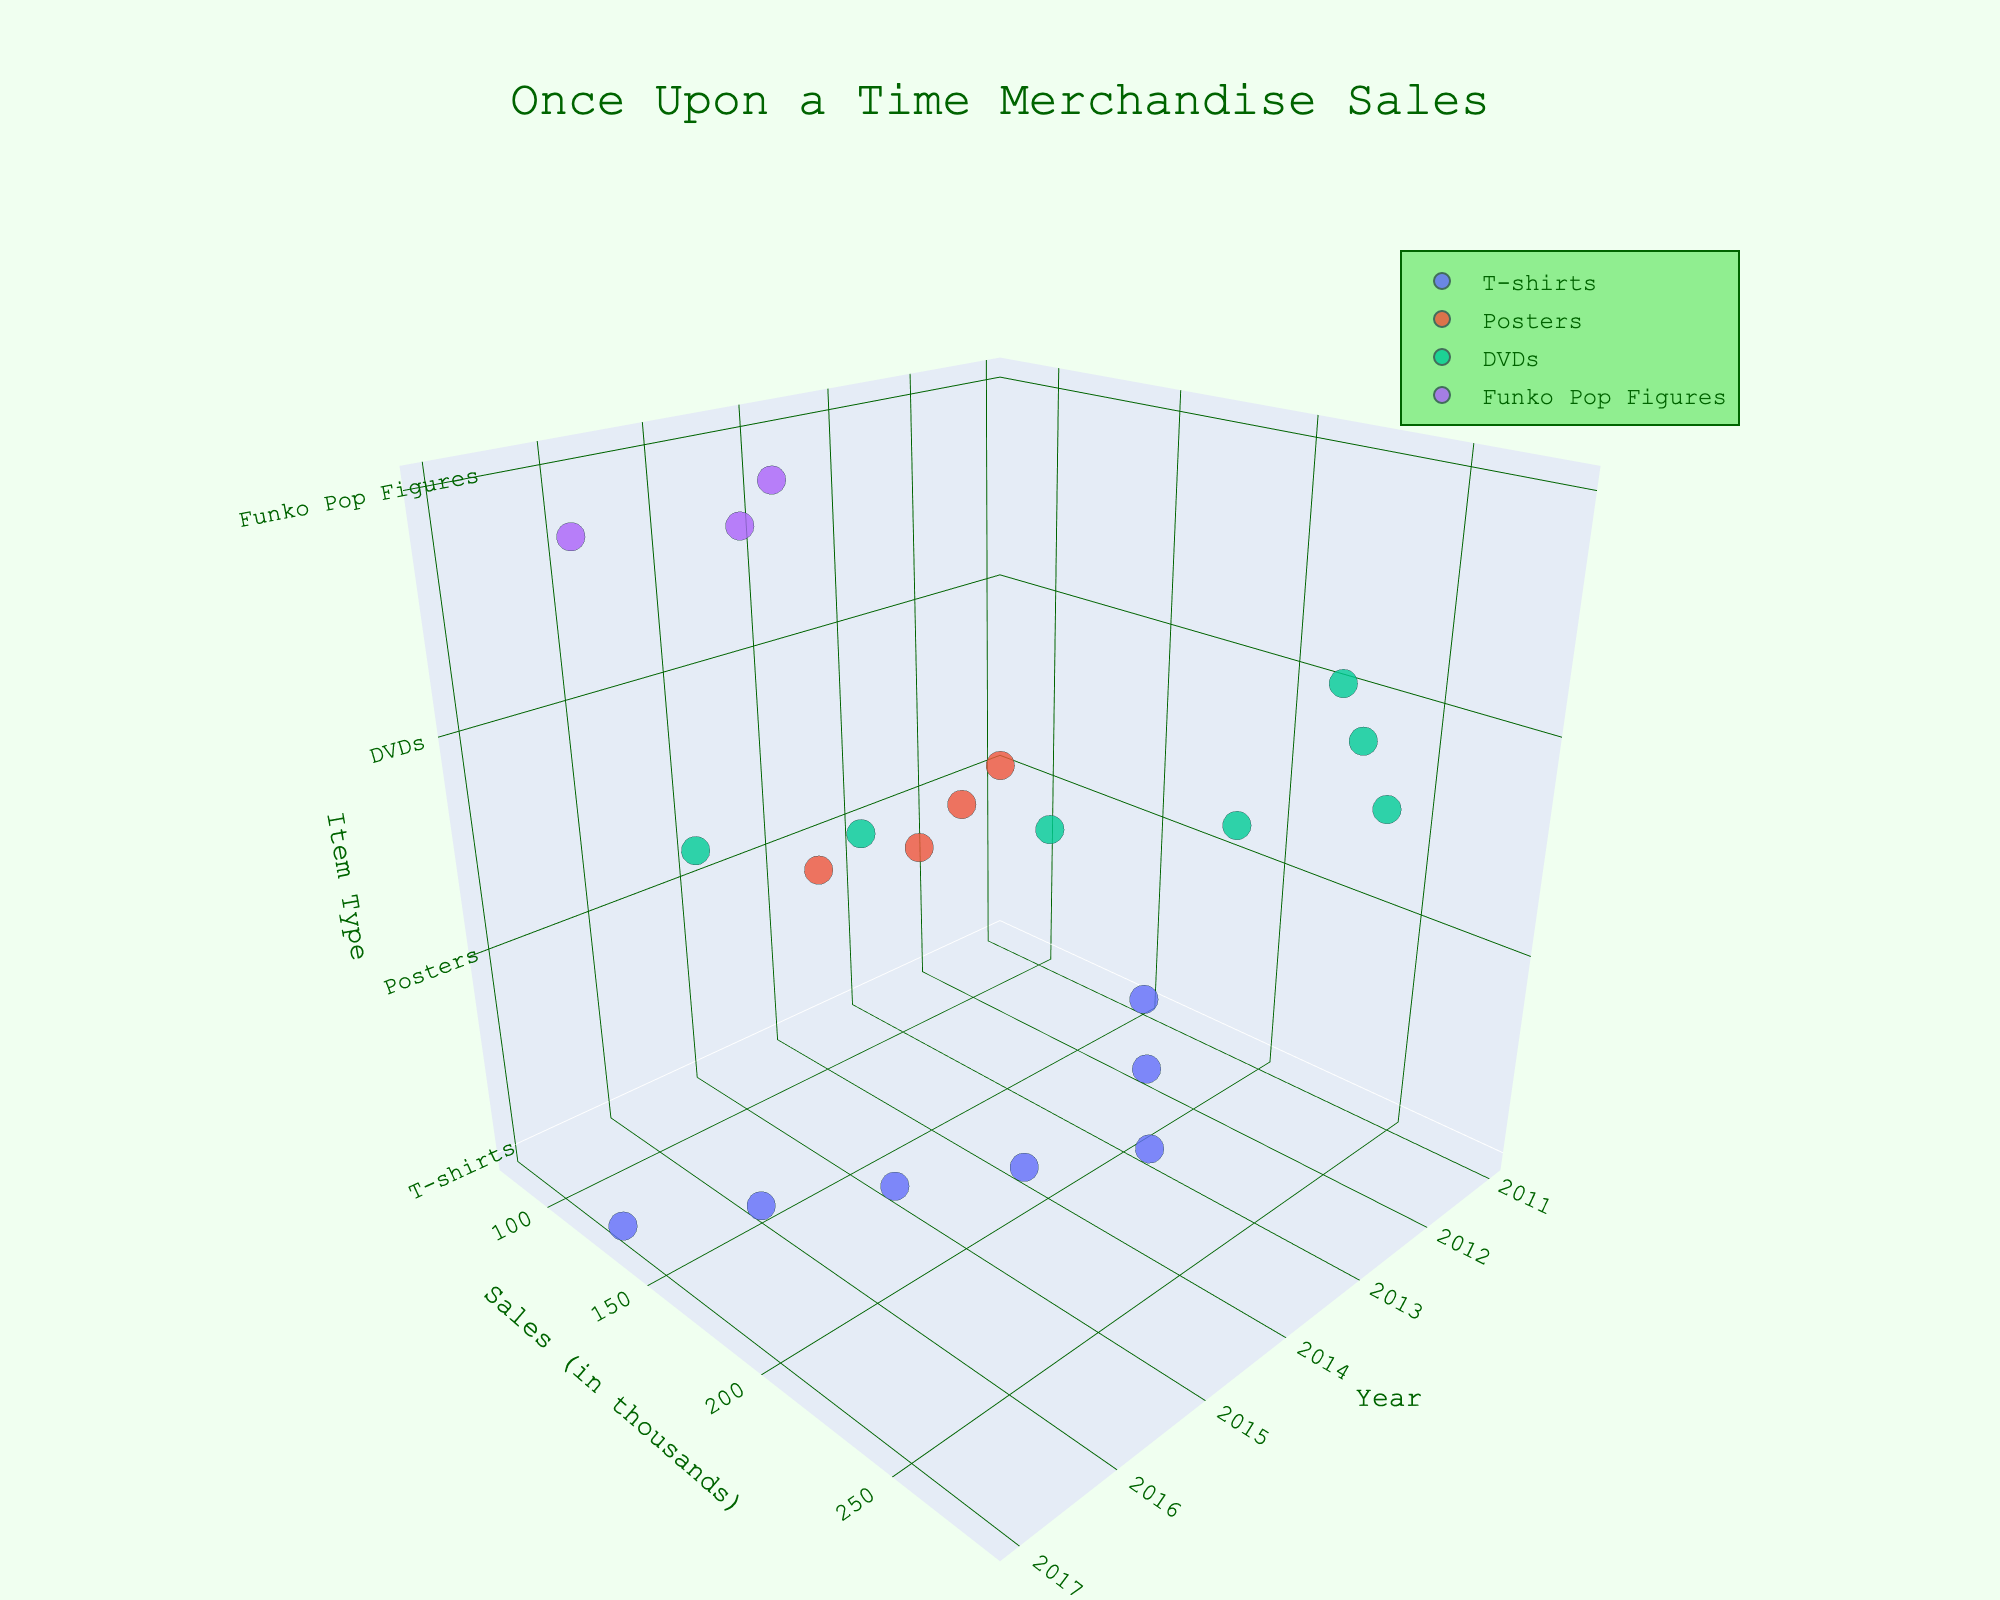What is the title of the 3D plot? The title is located at the top-center of the plot and is usually the most emphasized text. It is displayed in a larger font size compared to other text elements.
Answer: Once Upon a Time Merchandise Sales Which item had the highest sales in 2013? Check the y-axis values for 2013, look for the item with the highest point in sales, and note the item type from the z-axis.
Answer: DVDs How do the sales of T-shirts in 2017 compare to those in 2014? Locate the points representing T-shirt sales in 2014 and 2017 on the plot. Compare the y-axis values (sales in thousands) between these two years.
Answer: Sales decreased What is the trend of Funko Pop Figures' sales from 2015 to 2017? Observe the sales points for Funko Pop Figures for the years 2015 to 2017 on the plot. Identify whether the points show an increasing, decreasing, or stable trend.
Answer: Decreasing What are the axes labels of the 3D plot? The labels can be found near the respective axes. The x, y, and z axes each have a title displayed next to them.
Answer: Year, Sales (in thousands), Item Type In which year were the overall merchandise sales the highest? Sum the sales values (y-axis) for each year across all item types. Identify the year with the highest total sum.
Answer: 2013 Which item type shows the greatest variance in sales over the years? Compare the spread of the sales points (y-axis values) for each item type across different years. Identify the item type with the most significant range or fluctuations in sales.
Answer: T-shirts How does the sales trend for DVDs change from 2011 to 2017? Trace the points representing DVD sales from 2011 to 2017. Note how the y-axis (sales in thousands) values change over this period.
Answer: Decreasing Which year had the lowest sales for Posters? Look for the points representing Poster sales and identify the year where the y-axis value is the lowest.
Answer: 2011 